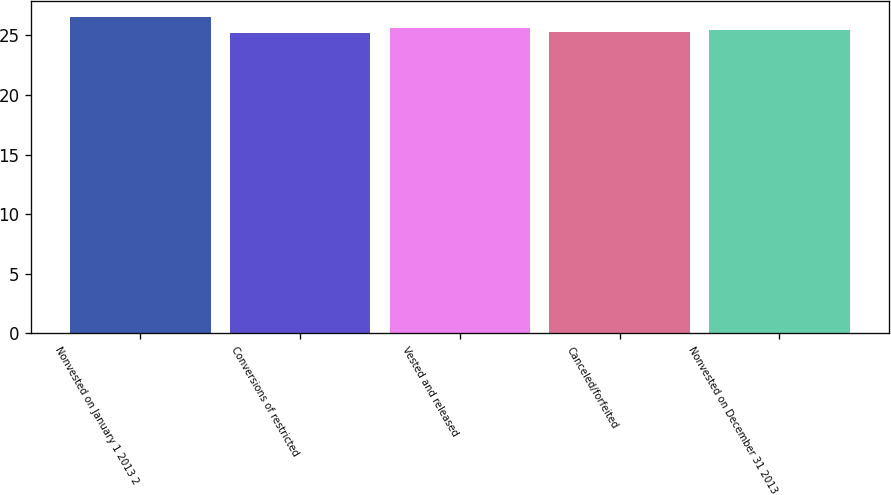Convert chart. <chart><loc_0><loc_0><loc_500><loc_500><bar_chart><fcel>Nonvested on January 1 2013 2<fcel>Conversions of restricted<fcel>Vested and released<fcel>Canceled/forfeited<fcel>Nonvested on December 31 2013<nl><fcel>26.54<fcel>25.17<fcel>25.59<fcel>25.31<fcel>25.45<nl></chart> 